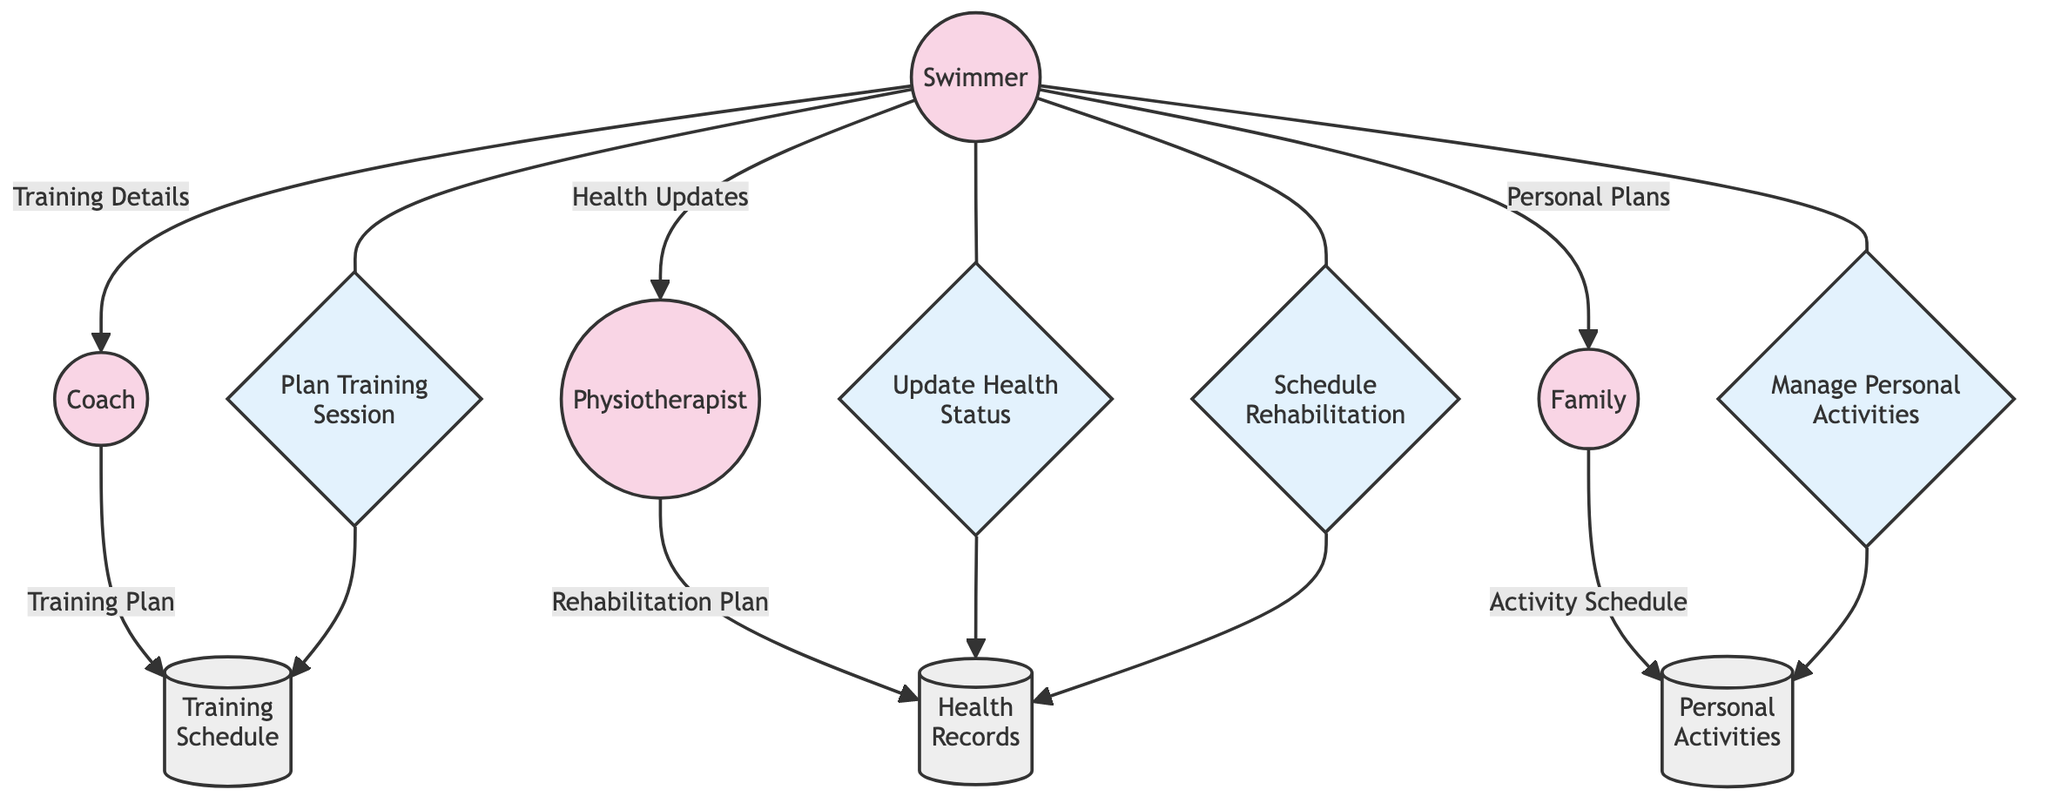What are the entities in the diagram? The diagram displays four entities: Swimmer, Coach, Physiotherapist, and Family. Each entity is a separate role involved in managing training and personal life.
Answer: Swimmer, Coach, Physiotherapist, Family How many data stores are represented in the diagram? The diagram contains three data stores: Training Schedule, Personal Activities, and Health Records. The count of data stores can be directly viewed in the diagram.
Answer: 3 Who receives the Training Plan from the Coach? The Training Plan flows from the Coach to the Training Schedule, indicating that the Training Schedule is updated with new plans by the Coach.
Answer: Training Schedule What process does the Physiotherapist perform after receiving Health Updates? After obtaining Health Updates from the Swimmer, the Physiotherapist follows the process of Updating Health Status, which is concerned with tracking the swimmer's health.
Answer: Update Health Status What type of relationship exists between Swimmer and Family? The relationship between the Swimmer and Family is that of sharing Personal Plans, indicating that the Swimmer communicates personal life commitments to the Family.
Answer: Share Which process is linked to managing personal activities? The Manage Personal Activities process is specifically linked to the Family, as it describes how the Swimmer manages personal life commitments with them.
Answer: Manage Personal Activities What does the Health Records database keep track of? The Health Records database is designed to keep track of changes related to health and rehabilitation progress updated by the Physiotherapist.
Answer: Health and rehabilitation progress What is the main data flow from the Family to the Personal Activities? The main data flow from the Family to Personal Activities is the Activity Schedule, indicating that updated schedules for personal commitments are communicated back to the database.
Answer: Activity Schedule How does the Swimmer update the Physiotherapist about their health? The Swimmer updates the Physiotherapist on their health through the data flow known as Health Updates, conveying current health status.
Answer: Health Updates 